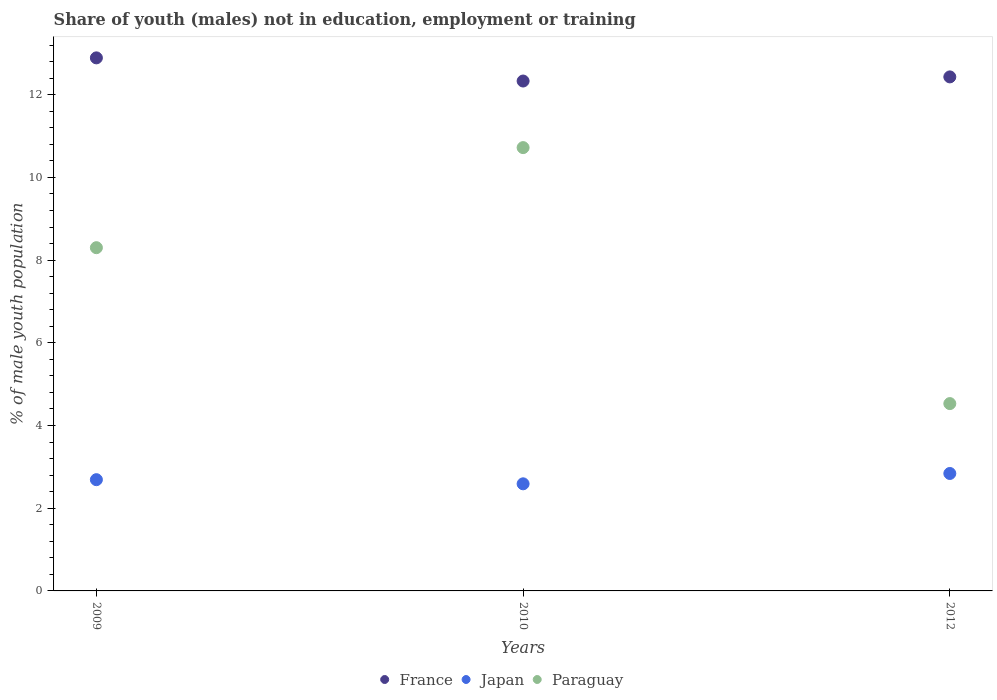What is the percentage of unemployed males population in in Japan in 2010?
Make the answer very short. 2.59. Across all years, what is the maximum percentage of unemployed males population in in France?
Offer a terse response. 12.89. Across all years, what is the minimum percentage of unemployed males population in in France?
Ensure brevity in your answer.  12.33. In which year was the percentage of unemployed males population in in Paraguay maximum?
Offer a terse response. 2010. In which year was the percentage of unemployed males population in in Paraguay minimum?
Your answer should be compact. 2012. What is the total percentage of unemployed males population in in Japan in the graph?
Provide a succinct answer. 8.12. What is the difference between the percentage of unemployed males population in in Japan in 2009 and that in 2010?
Your response must be concise. 0.1. What is the difference between the percentage of unemployed males population in in France in 2009 and the percentage of unemployed males population in in Paraguay in 2012?
Your answer should be very brief. 8.36. What is the average percentage of unemployed males population in in Japan per year?
Your answer should be compact. 2.71. In the year 2012, what is the difference between the percentage of unemployed males population in in France and percentage of unemployed males population in in Japan?
Your answer should be compact. 9.59. What is the ratio of the percentage of unemployed males population in in Japan in 2009 to that in 2010?
Give a very brief answer. 1.04. Is the percentage of unemployed males population in in Japan in 2009 less than that in 2012?
Ensure brevity in your answer.  Yes. What is the difference between the highest and the second highest percentage of unemployed males population in in Paraguay?
Make the answer very short. 2.42. What is the difference between the highest and the lowest percentage of unemployed males population in in Paraguay?
Provide a succinct answer. 6.19. Is the sum of the percentage of unemployed males population in in Paraguay in 2009 and 2010 greater than the maximum percentage of unemployed males population in in Japan across all years?
Provide a succinct answer. Yes. Is the percentage of unemployed males population in in France strictly greater than the percentage of unemployed males population in in Paraguay over the years?
Ensure brevity in your answer.  Yes. Is the percentage of unemployed males population in in Paraguay strictly less than the percentage of unemployed males population in in Japan over the years?
Keep it short and to the point. No. How many dotlines are there?
Provide a succinct answer. 3. Are the values on the major ticks of Y-axis written in scientific E-notation?
Give a very brief answer. No. Does the graph contain any zero values?
Ensure brevity in your answer.  No. How are the legend labels stacked?
Provide a short and direct response. Horizontal. What is the title of the graph?
Your answer should be compact. Share of youth (males) not in education, employment or training. Does "Euro area" appear as one of the legend labels in the graph?
Provide a short and direct response. No. What is the label or title of the Y-axis?
Provide a short and direct response. % of male youth population. What is the % of male youth population of France in 2009?
Give a very brief answer. 12.89. What is the % of male youth population of Japan in 2009?
Keep it short and to the point. 2.69. What is the % of male youth population of Paraguay in 2009?
Your response must be concise. 8.3. What is the % of male youth population in France in 2010?
Your answer should be very brief. 12.33. What is the % of male youth population in Japan in 2010?
Keep it short and to the point. 2.59. What is the % of male youth population of Paraguay in 2010?
Provide a succinct answer. 10.72. What is the % of male youth population of France in 2012?
Your answer should be compact. 12.43. What is the % of male youth population in Japan in 2012?
Offer a very short reply. 2.84. What is the % of male youth population of Paraguay in 2012?
Provide a short and direct response. 4.53. Across all years, what is the maximum % of male youth population in France?
Keep it short and to the point. 12.89. Across all years, what is the maximum % of male youth population in Japan?
Your answer should be compact. 2.84. Across all years, what is the maximum % of male youth population in Paraguay?
Ensure brevity in your answer.  10.72. Across all years, what is the minimum % of male youth population of France?
Your answer should be compact. 12.33. Across all years, what is the minimum % of male youth population in Japan?
Offer a terse response. 2.59. Across all years, what is the minimum % of male youth population in Paraguay?
Your response must be concise. 4.53. What is the total % of male youth population in France in the graph?
Your answer should be very brief. 37.65. What is the total % of male youth population in Japan in the graph?
Provide a short and direct response. 8.12. What is the total % of male youth population in Paraguay in the graph?
Make the answer very short. 23.55. What is the difference between the % of male youth population of France in 2009 and that in 2010?
Make the answer very short. 0.56. What is the difference between the % of male youth population in Paraguay in 2009 and that in 2010?
Your answer should be very brief. -2.42. What is the difference between the % of male youth population of France in 2009 and that in 2012?
Your answer should be compact. 0.46. What is the difference between the % of male youth population of Paraguay in 2009 and that in 2012?
Provide a short and direct response. 3.77. What is the difference between the % of male youth population of France in 2010 and that in 2012?
Provide a succinct answer. -0.1. What is the difference between the % of male youth population of Japan in 2010 and that in 2012?
Your response must be concise. -0.25. What is the difference between the % of male youth population of Paraguay in 2010 and that in 2012?
Offer a very short reply. 6.19. What is the difference between the % of male youth population in France in 2009 and the % of male youth population in Japan in 2010?
Provide a succinct answer. 10.3. What is the difference between the % of male youth population in France in 2009 and the % of male youth population in Paraguay in 2010?
Your answer should be compact. 2.17. What is the difference between the % of male youth population of Japan in 2009 and the % of male youth population of Paraguay in 2010?
Your answer should be compact. -8.03. What is the difference between the % of male youth population of France in 2009 and the % of male youth population of Japan in 2012?
Ensure brevity in your answer.  10.05. What is the difference between the % of male youth population of France in 2009 and the % of male youth population of Paraguay in 2012?
Your answer should be compact. 8.36. What is the difference between the % of male youth population of Japan in 2009 and the % of male youth population of Paraguay in 2012?
Your response must be concise. -1.84. What is the difference between the % of male youth population of France in 2010 and the % of male youth population of Japan in 2012?
Your answer should be compact. 9.49. What is the difference between the % of male youth population in Japan in 2010 and the % of male youth population in Paraguay in 2012?
Your response must be concise. -1.94. What is the average % of male youth population in France per year?
Offer a terse response. 12.55. What is the average % of male youth population in Japan per year?
Offer a terse response. 2.71. What is the average % of male youth population of Paraguay per year?
Offer a terse response. 7.85. In the year 2009, what is the difference between the % of male youth population in France and % of male youth population in Japan?
Provide a short and direct response. 10.2. In the year 2009, what is the difference between the % of male youth population of France and % of male youth population of Paraguay?
Your response must be concise. 4.59. In the year 2009, what is the difference between the % of male youth population of Japan and % of male youth population of Paraguay?
Provide a short and direct response. -5.61. In the year 2010, what is the difference between the % of male youth population of France and % of male youth population of Japan?
Your response must be concise. 9.74. In the year 2010, what is the difference between the % of male youth population in France and % of male youth population in Paraguay?
Ensure brevity in your answer.  1.61. In the year 2010, what is the difference between the % of male youth population in Japan and % of male youth population in Paraguay?
Provide a short and direct response. -8.13. In the year 2012, what is the difference between the % of male youth population in France and % of male youth population in Japan?
Your answer should be compact. 9.59. In the year 2012, what is the difference between the % of male youth population in France and % of male youth population in Paraguay?
Keep it short and to the point. 7.9. In the year 2012, what is the difference between the % of male youth population in Japan and % of male youth population in Paraguay?
Keep it short and to the point. -1.69. What is the ratio of the % of male youth population in France in 2009 to that in 2010?
Provide a succinct answer. 1.05. What is the ratio of the % of male youth population in Japan in 2009 to that in 2010?
Provide a succinct answer. 1.04. What is the ratio of the % of male youth population of Paraguay in 2009 to that in 2010?
Provide a succinct answer. 0.77. What is the ratio of the % of male youth population in Japan in 2009 to that in 2012?
Your response must be concise. 0.95. What is the ratio of the % of male youth population of Paraguay in 2009 to that in 2012?
Keep it short and to the point. 1.83. What is the ratio of the % of male youth population in France in 2010 to that in 2012?
Your response must be concise. 0.99. What is the ratio of the % of male youth population of Japan in 2010 to that in 2012?
Provide a succinct answer. 0.91. What is the ratio of the % of male youth population in Paraguay in 2010 to that in 2012?
Offer a very short reply. 2.37. What is the difference between the highest and the second highest % of male youth population in France?
Provide a short and direct response. 0.46. What is the difference between the highest and the second highest % of male youth population in Japan?
Give a very brief answer. 0.15. What is the difference between the highest and the second highest % of male youth population in Paraguay?
Your answer should be very brief. 2.42. What is the difference between the highest and the lowest % of male youth population in France?
Give a very brief answer. 0.56. What is the difference between the highest and the lowest % of male youth population of Paraguay?
Keep it short and to the point. 6.19. 